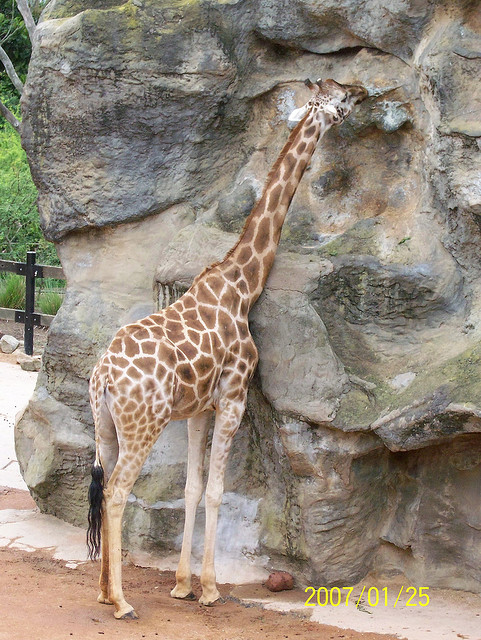Identify and read out the text in this image. 2007 01 25 